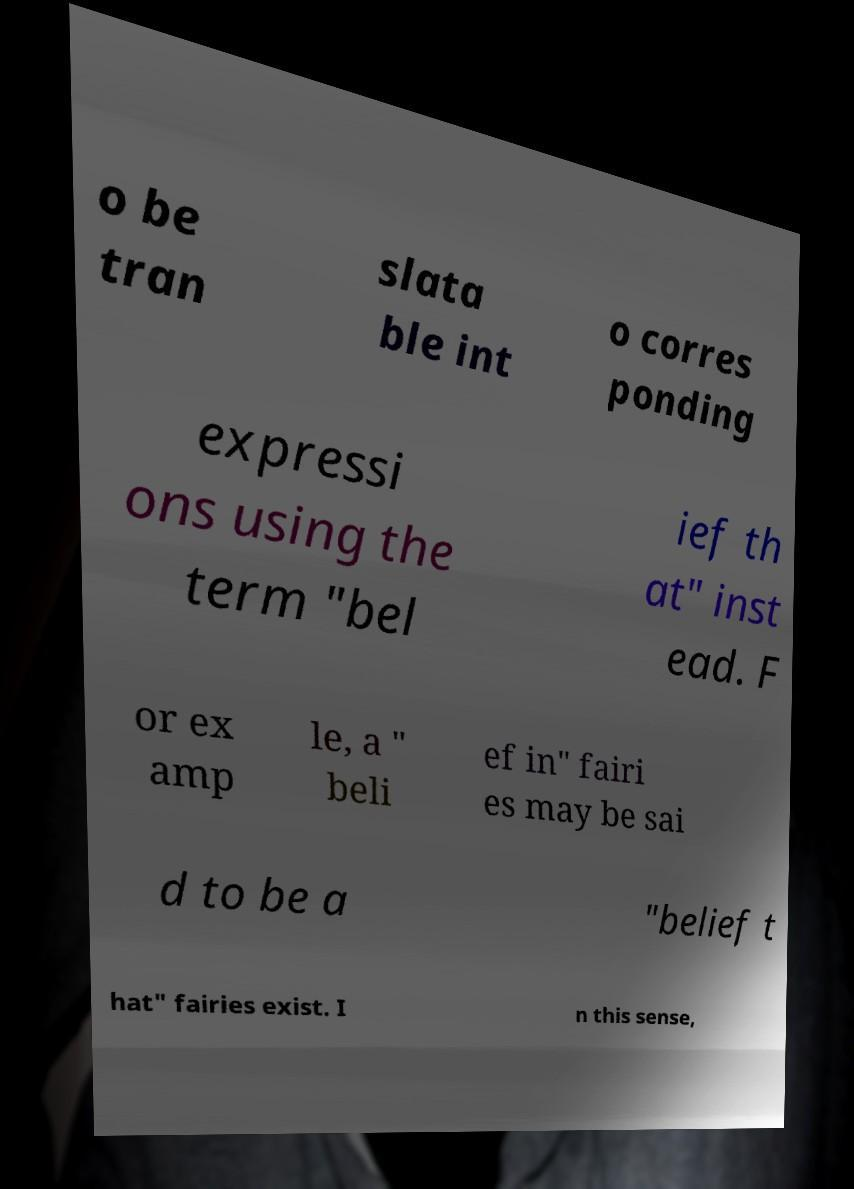Please identify and transcribe the text found in this image. o be tran slata ble int o corres ponding expressi ons using the term "bel ief th at" inst ead. F or ex amp le, a " beli ef in" fairi es may be sai d to be a "belief t hat" fairies exist. I n this sense, 